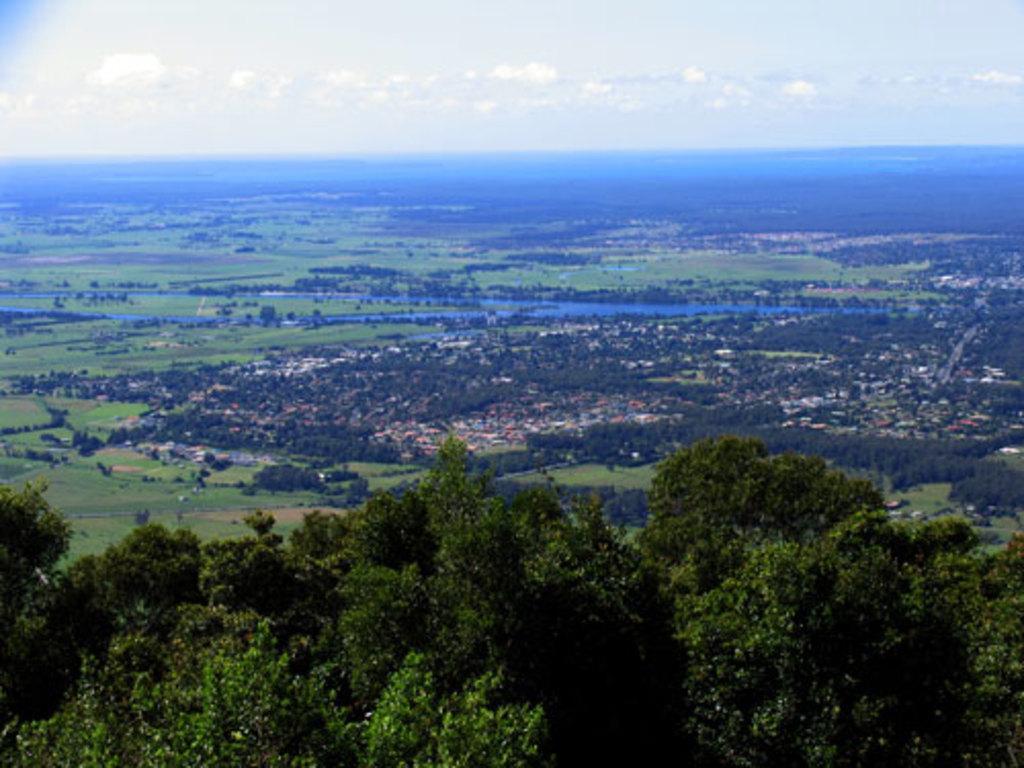Please provide a concise description of this image. In this picture, we can see some buildings, a few trees, small plants, ground, river and the sky with clouds. 